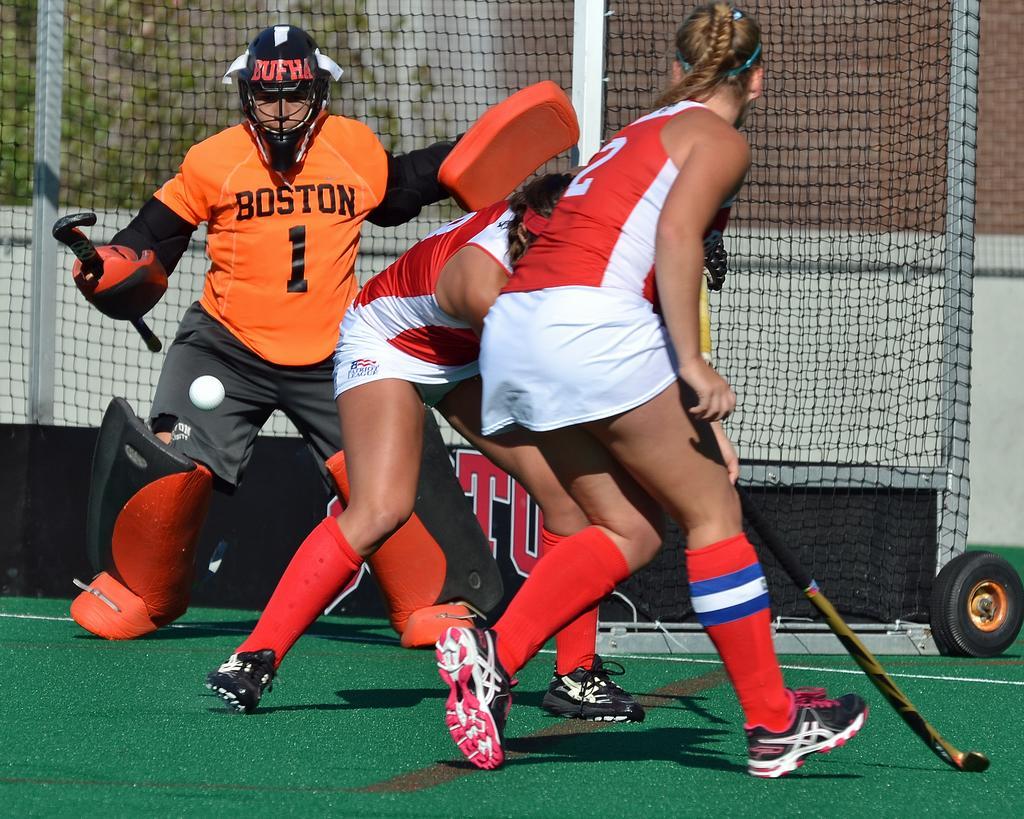Please provide a concise description of this image. In this picture we can see women playing hockey on the field holding hockey sticks. 